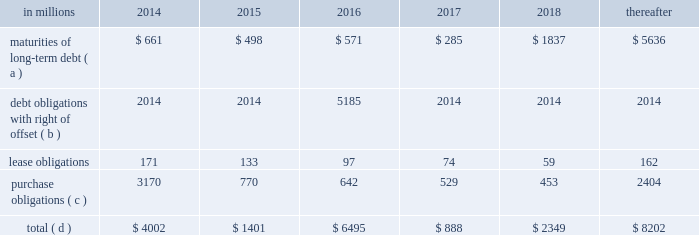Average cost of debt from 7.1% ( 7.1 % ) to an effective rate of 6.9% ( 6.9 % ) .
The inclusion of the offsetting interest income from short-term investments reduced this effective rate to 6.26% ( 6.26 % ) .
Other financing activities during 2011 included the issuance of approximately 0.3 million shares of treasury stock for various incentive plans and the acquisition of 1.0 million shares of treasury stock primarily related to restricted stock withholding taxes .
Payments of restricted stock withholding taxes totaled $ 30 million .
Off-balance sheet variable interest entities information concerning off-balance sheet variable interest entities is set forth in note 12 variable interest entities and preferred securities of subsidiaries on pages 72 through 75 of item 8 .
Financial statements and supplementary data for discussion .
Liquidity and capital resources outlook for 2014 capital expenditures and long-term debt international paper expects to be able to meet projected capital expenditures , service existing debt and meet working capital and dividend requirements during 2014 through current cash balances and cash from operations .
Additionally , the company has existing credit facilities totaling $ 2.0 billion .
The company was in compliance with all its debt covenants at december 31 , 2013 .
The company 2019s financial covenants require the maintenance of a minimum net worth of $ 9 billion and a total debt-to- capital ratio of less than 60% ( 60 % ) .
Net worth is defined as the sum of common stock , paid-in capital and retained earnings , less treasury stock plus any cumulative goodwill impairment charges .
The calculation also excludes accumulated other comprehensive income/ loss and nonrecourse financial liabilities of special purpose entities .
The total debt-to-capital ratio is defined as total debt divided by the sum of total debt plus net worth .
At december 31 , 2013 , international paper 2019s net worth was $ 15.1 billion , and the total-debt- to-capital ratio was 39% ( 39 % ) .
The company will continue to rely upon debt and capital markets for the majority of any necessary long-term funding not provided by operating cash flows .
Funding decisions will be guided by our capital structure planning objectives .
The primary goals of the company 2019s capital structure planning are to maximize financial flexibility and preserve liquidity while reducing interest expense .
The majority of international paper 2019s debt is accessed through global public capital markets where we have a wide base of investors .
Maintaining an investment grade credit rating is an important element of international paper 2019s financing strategy .
At december 31 , 2013 , the company held long-term credit ratings of bbb ( stable outlook ) and baa3 ( stable outlook ) by s&p and moody 2019s , respectively .
Contractual obligations for future payments under existing debt and lease commitments and purchase obligations at december 31 , 2013 , were as follows: .
( a ) total debt includes scheduled principal payments only .
( b ) represents debt obligations borrowed from non-consolidated variable interest entities for which international paper has , and intends to effect , a legal right to offset these obligations with investments held in the entities .
Accordingly , in its consolidated balance sheet at december 31 , 2013 , international paper has offset approximately $ 5.2 billion of interests in the entities against this $ 5.2 billion of debt obligations held by the entities ( see note 12 variable interest entities and preferred securities of subsidiaries on pages 72 through 75 in item 8 .
Financial statements and supplementary data ) .
( c ) includes $ 3.3 billion relating to fiber supply agreements entered into at the time of the 2006 transformation plan forestland sales and in conjunction with the 2008 acquisition of weyerhaeuser company 2019s containerboard , packaging and recycling business .
( d ) not included in the above table due to the uncertainty as to the amount and timing of the payment are unrecognized tax benefits of approximately $ 146 million .
We consider the undistributed earnings of our foreign subsidiaries as of december 31 , 2013 , to be indefinitely reinvested and , accordingly , no u.s .
Income taxes have been provided thereon .
As of december 31 , 2013 , the amount of cash associated with indefinitely reinvested foreign earnings was approximately $ 900 million .
We do not anticipate the need to repatriate funds to the united states to satisfy domestic liquidity needs arising in the ordinary course of business , including liquidity needs associated with our domestic debt service requirements .
Pension obligations and funding at december 31 , 2013 , the projected benefit obligation for the company 2019s u.s .
Defined benefit plans determined under u.s .
Gaap was approximately $ 2.2 billion higher than the fair value of plan assets .
Approximately $ 1.8 billion of this amount relates to plans that are subject to minimum funding requirements .
Under current irs funding rules , the calculation of minimum funding requirements differs from the calculation of the present value of plan benefits ( the projected benefit obligation ) for accounting purposes .
In december 2008 , the worker , retiree and employer recovery act of 2008 ( wera ) was passed by the u.s .
Congress which provided for pension funding relief and technical corrections .
Funding .
In 2014 what percentage of contractual obligations for future payments under existing debt and lease commitments and purchase obligations at december 31 , 2013 was attributable to maturities of long-term debt? 
Computations: (661 / 4002)
Answer: 0.16517. 